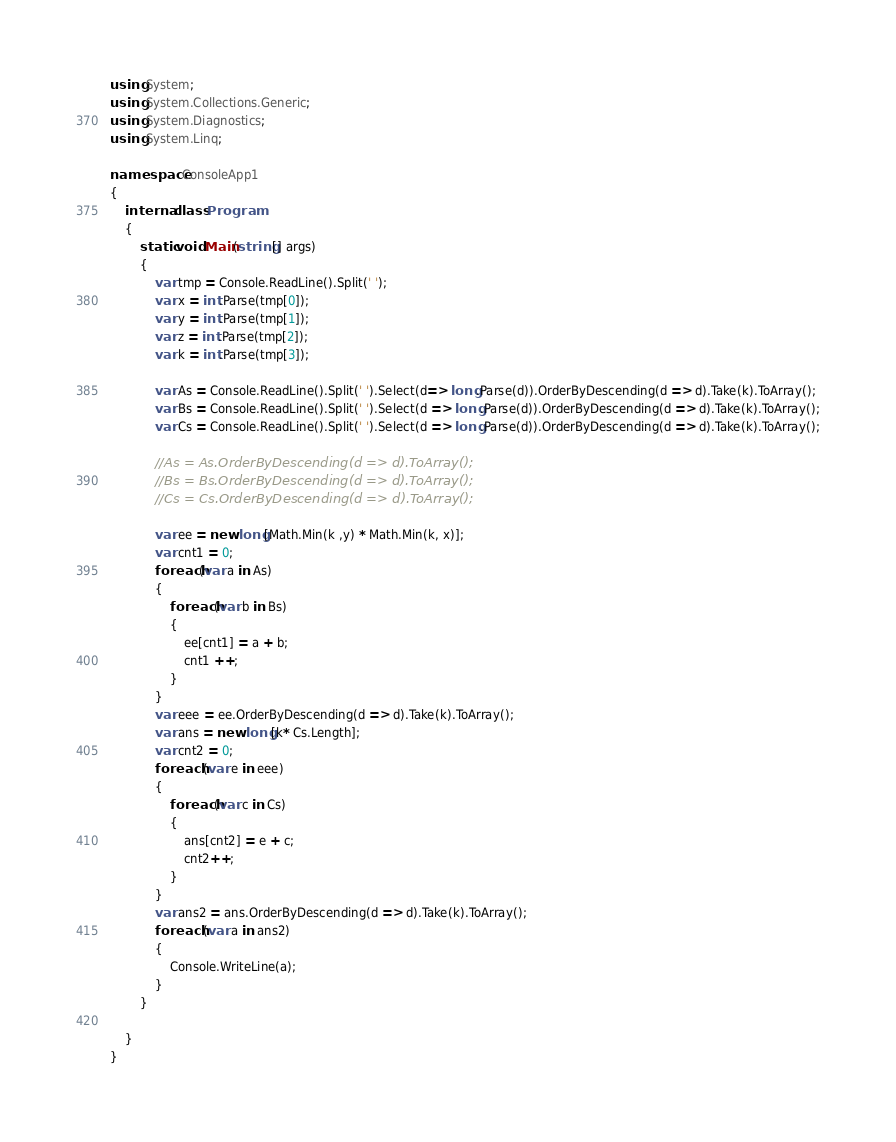<code> <loc_0><loc_0><loc_500><loc_500><_C#_>using System;
using System.Collections.Generic;
using System.Diagnostics;
using System.Linq;

namespace ConsoleApp1
{
    internal class Program
    {
        static void Main(string[] args)
        {
            var tmp = Console.ReadLine().Split(' ');
            var x = int.Parse(tmp[0]);
            var y = int.Parse(tmp[1]);
            var z = int.Parse(tmp[2]);
            var k = int.Parse(tmp[3]);

            var As = Console.ReadLine().Split(' ').Select(d=> long.Parse(d)).OrderByDescending(d => d).Take(k).ToArray();
            var Bs = Console.ReadLine().Split(' ').Select(d => long.Parse(d)).OrderByDescending(d => d).Take(k).ToArray();
            var Cs = Console.ReadLine().Split(' ').Select(d => long.Parse(d)).OrderByDescending(d => d).Take(k).ToArray();

            //As = As.OrderByDescending(d => d).ToArray();
            //Bs = Bs.OrderByDescending(d => d).ToArray();
            //Cs = Cs.OrderByDescending(d => d).ToArray();

            var ee = new long[Math.Min(k ,y) * Math.Min(k, x)];
            var cnt1 = 0;
            foreach(var a in As)
            {
                foreach(var b in Bs)
                {
                    ee[cnt1] = a + b;
                    cnt1 ++;
                }
            }
            var eee = ee.OrderByDescending(d => d).Take(k).ToArray();
            var ans = new long[k* Cs.Length];
            var cnt2 = 0;
            foreach (var e in eee)
            {
                foreach(var c in Cs)
                {
                    ans[cnt2] = e + c;
                    cnt2++;
                }
            }
            var ans2 = ans.OrderByDescending(d => d).Take(k).ToArray();
            foreach (var a in ans2)
            {
                Console.WriteLine(a);
            }
        }

    }
}
</code> 